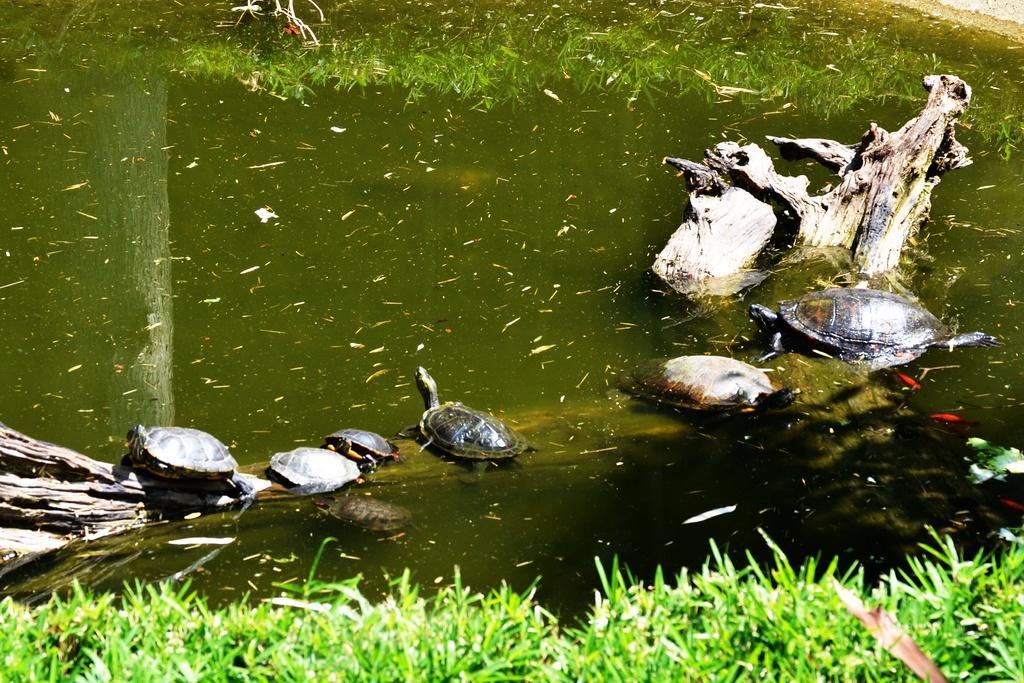Describe this image in one or two sentences. In this image there is a tree trunk in the water. On it there are small tortoises. At the bottom there is grass. In the middle there is water. 